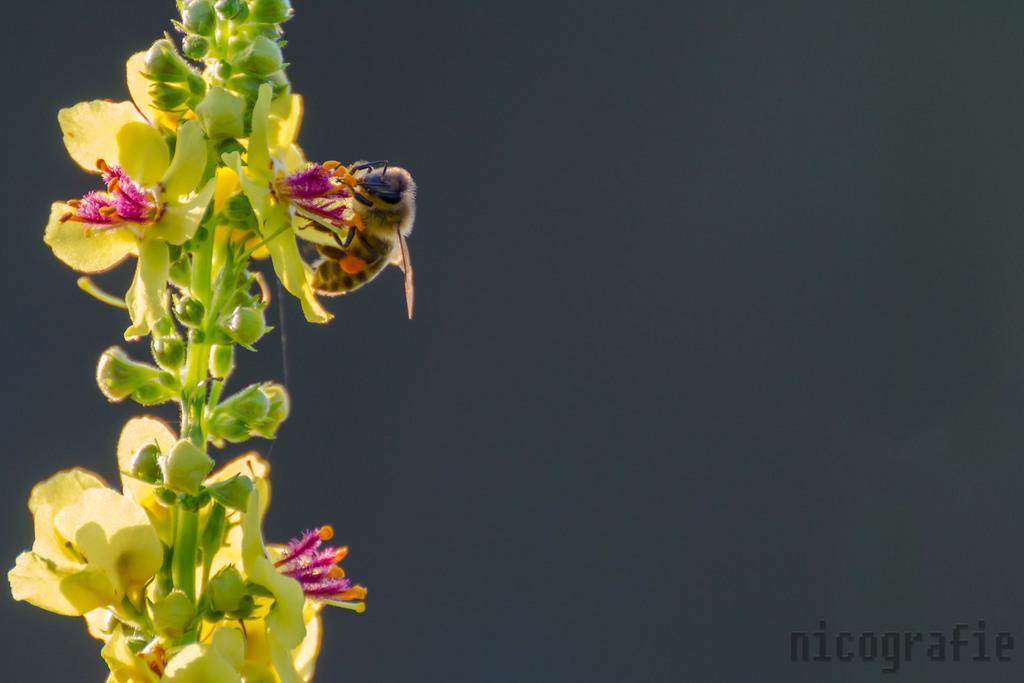Could you give a brief overview of what you see in this image? In this image we can see some flowers and buds, there is a bee on a flower. 